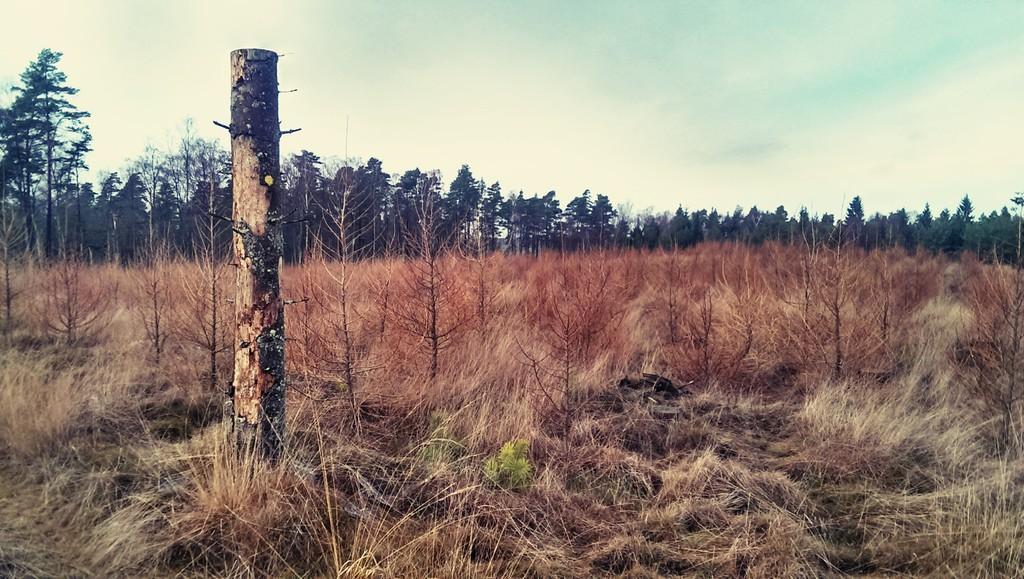Describe this image in one or two sentences. At the bottom we can see grass,bare plants and on the left side there is a wooden pole. In the background there are trees and clouds in the sky. 